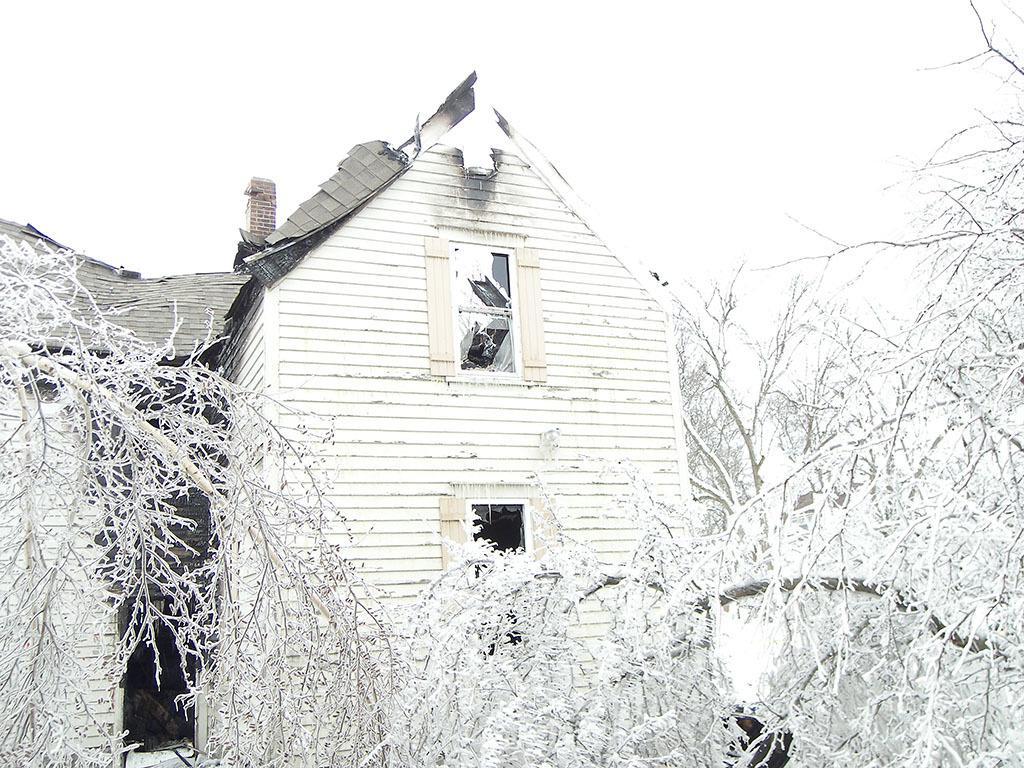Can you describe this image briefly? In the center of the image we can see a shed. At the bottom there are trees. In the background there is sky. 